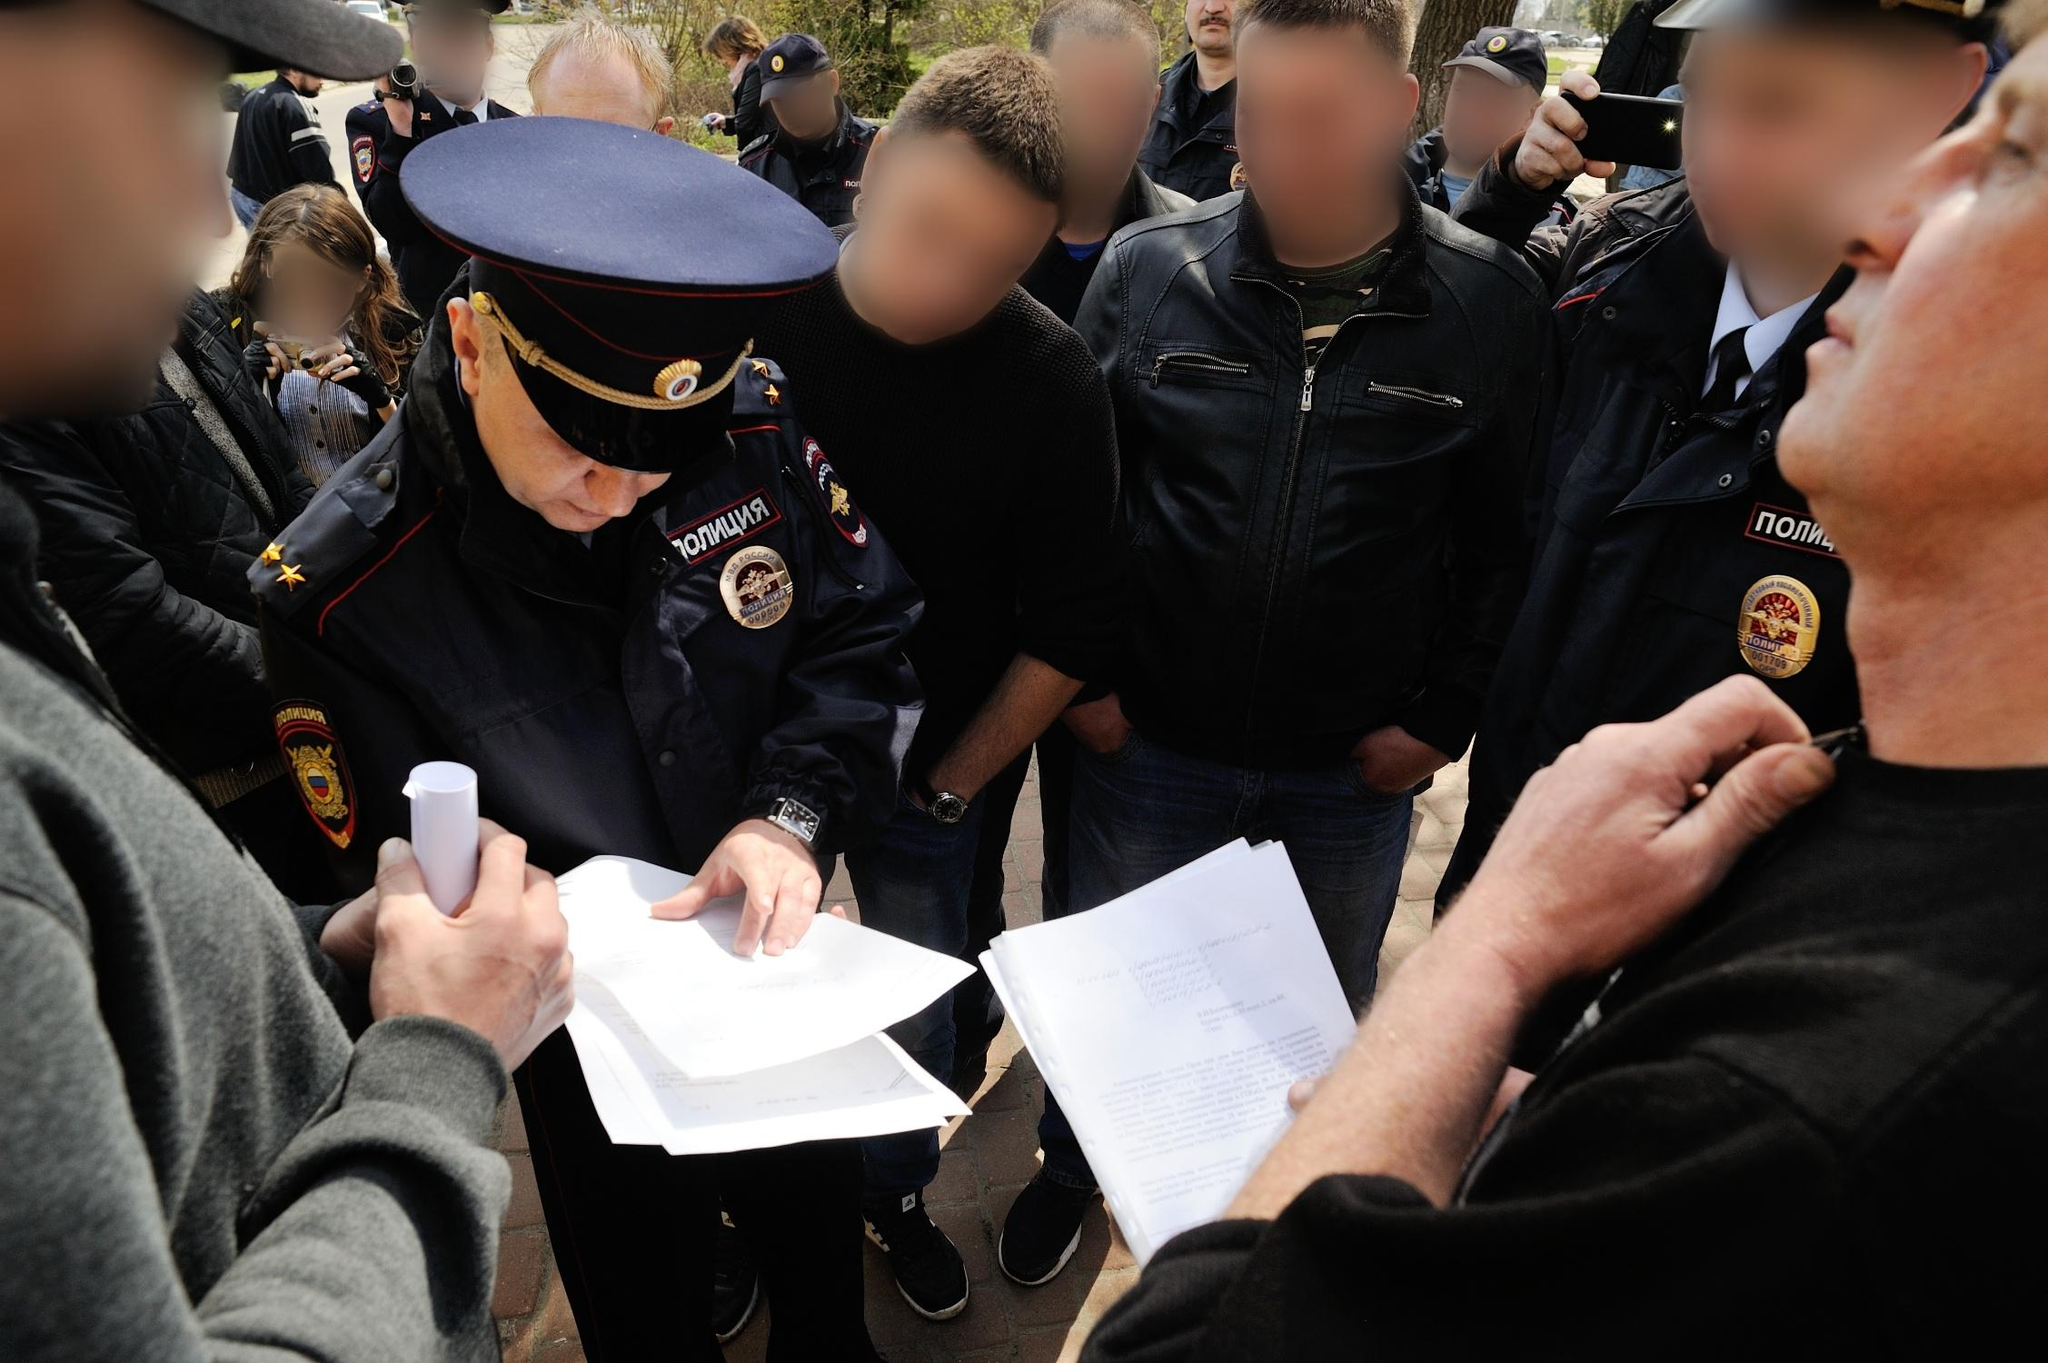Can you describe the uniforms and badges seen in the image? The officer at the center is dressed in a prominent blue uniform adorned with gold insignia on the shoulders, emphasizing his rank. His red hat with a detailed emblem also stands out, reinforcing his authoritative role. The badge on his uniform reads 'KOMANDA' in bold, underscoring his position. Another officer in the background wearing a similar uniform further establishes a sense of official presence. The meticulous details of the uniforms and badges suggest a formal and regulated environment, indicative of law enforcement or a structured organization. What might be the significance of the crowd gathering around the officer? The assembly around the officer could signify a critical moment, such as a public announcement, an inspection, or the distribution of important information. The presence of multiple people holding documents adds weight to this interpretation. This gathering could also be part of a public demonstration or a community meeting, underscoring the officer's role in maintaining order or disseminating relevant information to the public. The blurred faces focus the narrative on the interactions and the actions of the officer, hinting at a moment of significance in a communal or civic scenario. 